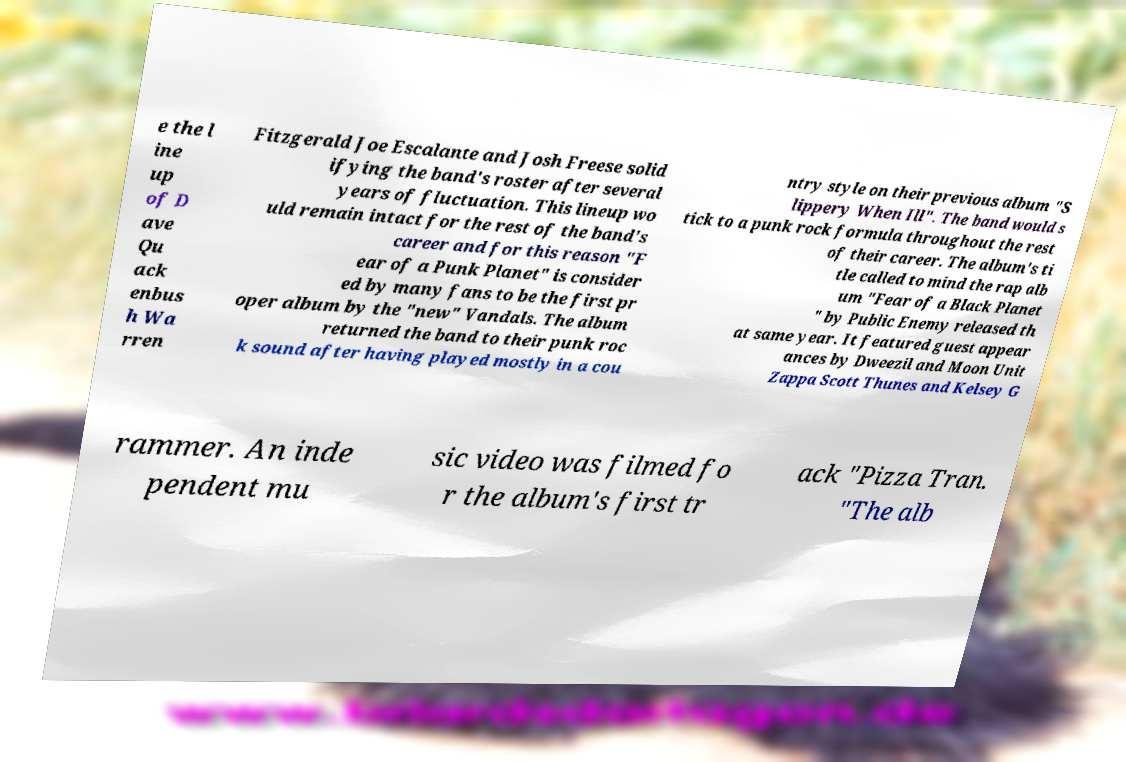Can you accurately transcribe the text from the provided image for me? e the l ine up of D ave Qu ack enbus h Wa rren Fitzgerald Joe Escalante and Josh Freese solid ifying the band's roster after several years of fluctuation. This lineup wo uld remain intact for the rest of the band's career and for this reason "F ear of a Punk Planet" is consider ed by many fans to be the first pr oper album by the "new" Vandals. The album returned the band to their punk roc k sound after having played mostly in a cou ntry style on their previous album "S lippery When Ill". The band would s tick to a punk rock formula throughout the rest of their career. The album's ti tle called to mind the rap alb um "Fear of a Black Planet " by Public Enemy released th at same year. It featured guest appear ances by Dweezil and Moon Unit Zappa Scott Thunes and Kelsey G rammer. An inde pendent mu sic video was filmed fo r the album's first tr ack "Pizza Tran. "The alb 